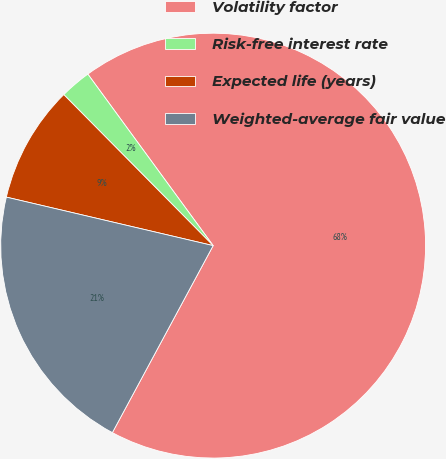Convert chart to OTSL. <chart><loc_0><loc_0><loc_500><loc_500><pie_chart><fcel>Volatility factor<fcel>Risk-free interest rate<fcel>Expected life (years)<fcel>Weighted-average fair value<nl><fcel>67.91%<fcel>2.37%<fcel>8.92%<fcel>20.8%<nl></chart> 